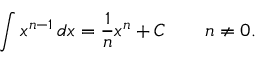<formula> <loc_0><loc_0><loc_500><loc_500>\int x ^ { n - 1 } \, d x = { \frac { 1 } { n } } x ^ { n } + C \quad n \neq 0 .</formula> 